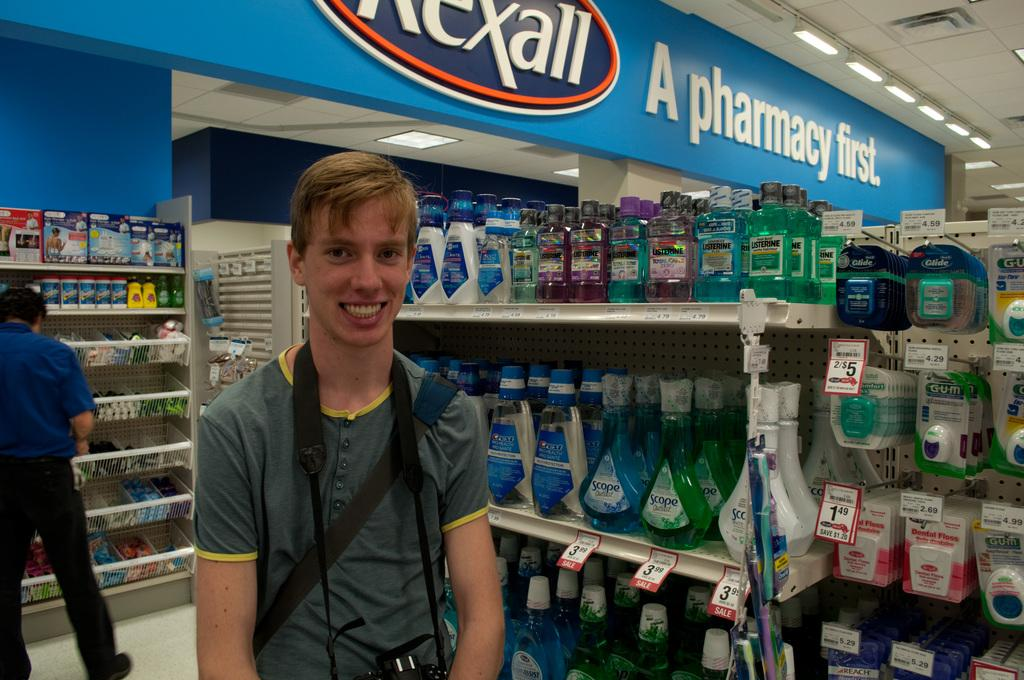<image>
Relay a brief, clear account of the picture shown. A young man standing in a store aisle with a sign about a pharmacy above him. 